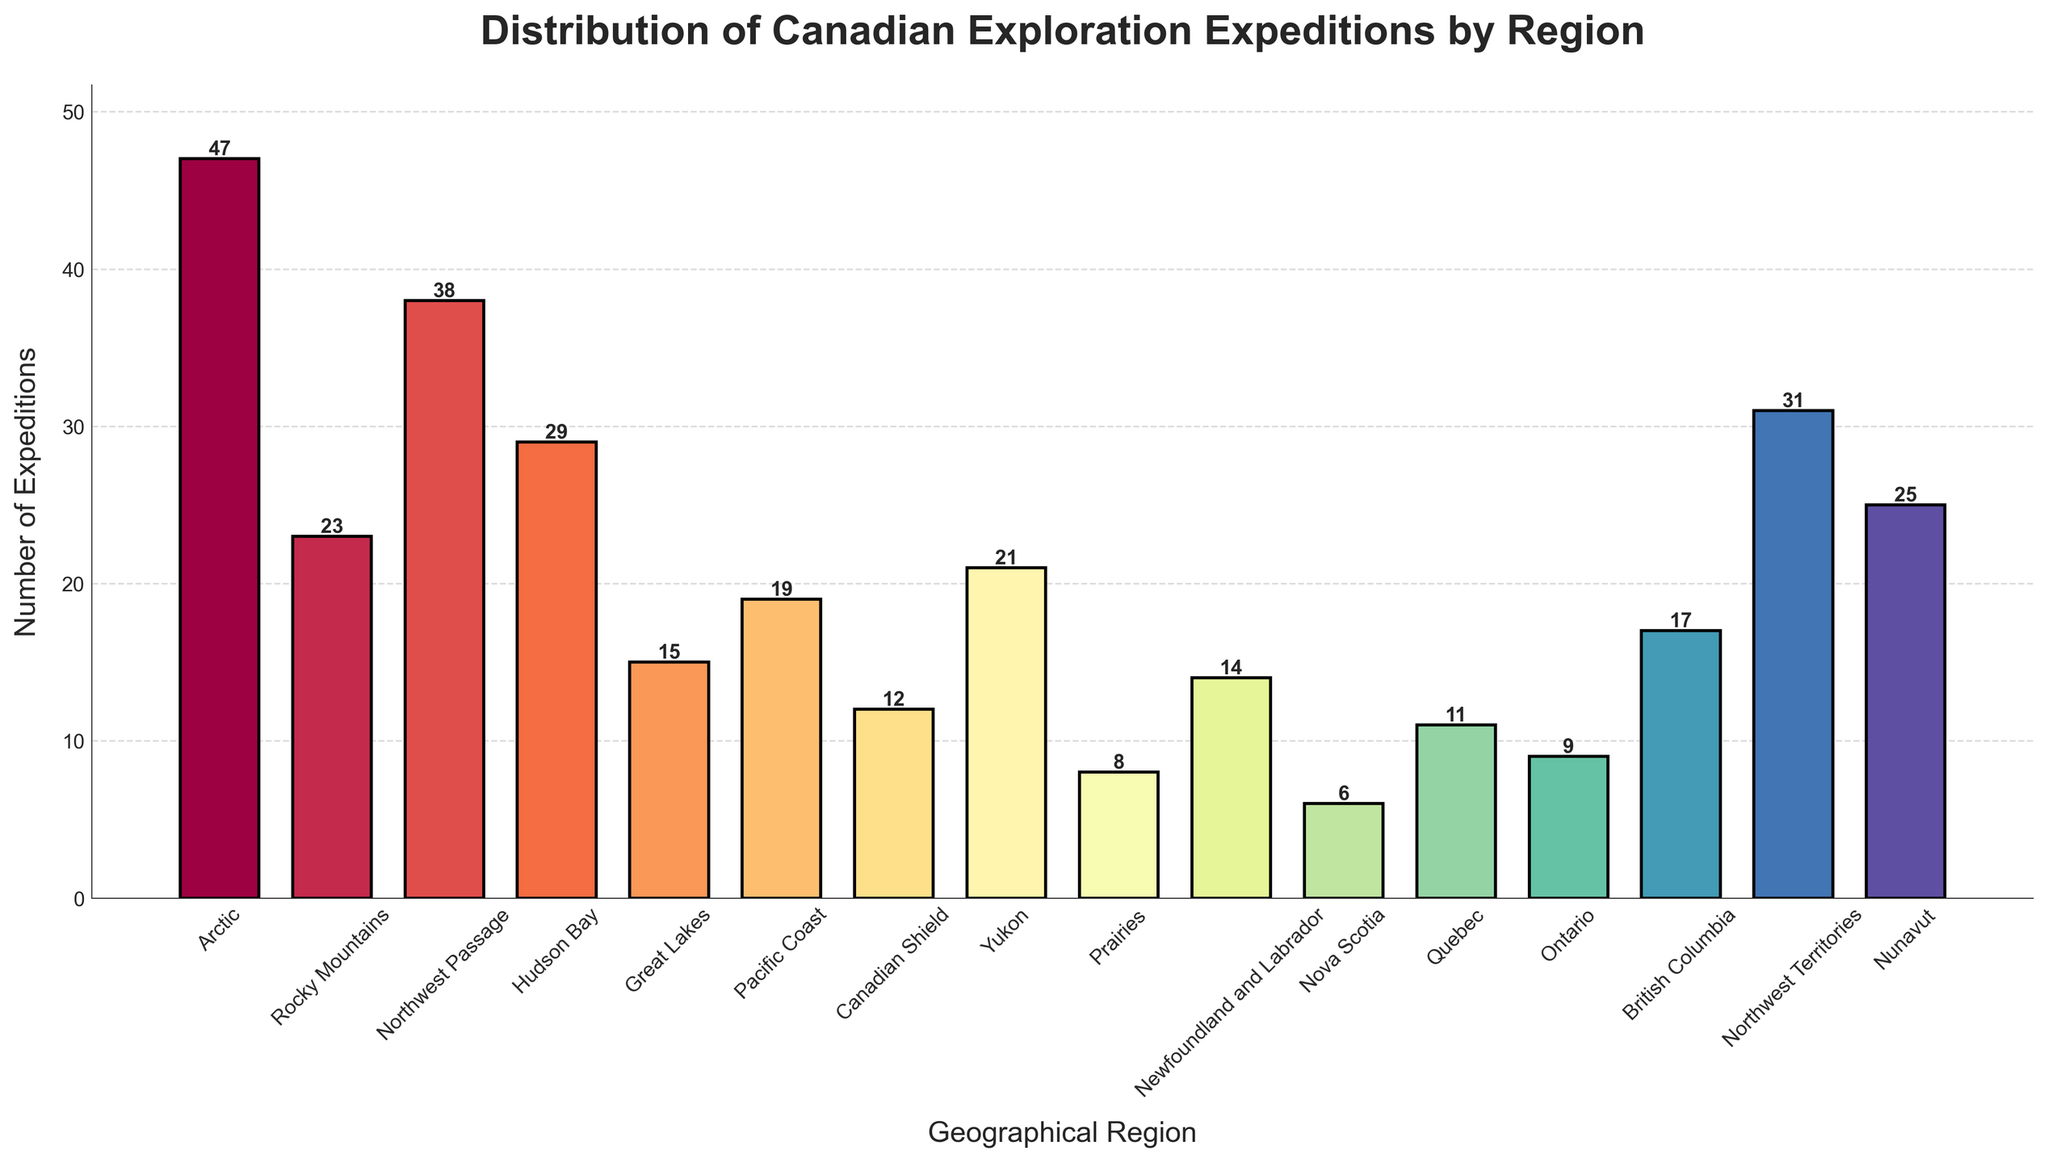Which region had the highest number of exploration expeditions? To determine the region with the highest number of exploration expeditions, look for the bar that reaches the highest value on the y-axis. The Arctic region has the tallest bar, indicating it had the most expeditions.
Answer: Arctic Which region had the second highest number of expeditions? To find the second highest number, look for the bar that is slightly shorter than the highest one. The Northwest Territories region has the second tallest bar, following the Arctic.
Answer: Northwest Territories How many more expeditions took place in the Rocky Mountains compared to Quebec? First, find the bars corresponding to Rocky Mountains and Quebec. The Rocky Mountains had 23 expeditions, and Quebec had 11. Subtract the smaller value from the larger value: 23 - 11 = 12.
Answer: 12 What is the total number of expeditions in the Pacific Coast, Yukon, and Nova Scotia regions? Add the number of expeditions for these regions: Pacific Coast (19), Yukon (21), and Nova Scotia (6). The total is 19 + 21 + 6 = 46.
Answer: 46 Which region had the fewest expeditions, and how many did it have? Identify the shortest bar. The Nova Scotia region has the shortest bar with 6 expeditions.
Answer: Nova Scotia, 6 Are there more expeditions in Nunavut or Hudson Bay? Compare the heights of the bars for Nunavut and Hudson Bay. Nunavut had 25 expeditions while Hudson Bay had 29. Hudson Bay has more expeditions.
Answer: Hudson Bay What is the average number of expeditions across all regions? Sum the number of expeditions for all regions and divide by the number of regions. Total expeditions: 47 + 23 + 38 + 29 + 15 + 19 + 12 + 21 + 8 + 14 + 6 + 11 + 9 + 17 + 31 + 25 = 325. Number of regions: 16. Average = 325 / 16 ≈ 20.31.
Answer: 20.31 What is the difference in the number of expeditions between the Great Lakes and Ontario regions? Compare the bars for Great Lakes and Ontario. The Great Lakes had 15 expeditions while Ontario had 9. The difference is 15 - 9 = 6.
Answer: 6 Which regions had 19 or more expeditions? Identify the bars with heights equal to or greater than 19. They are Arctic (47), Northwest Passage (38), Hudson Bay (29), Northwest Territories (31), Nunavut (25), and Pacific Coast (19).
Answer: Arctic, Northwest Passage, Hudson Bay, Northwest Territories, Nunavut, Pacific Coast 